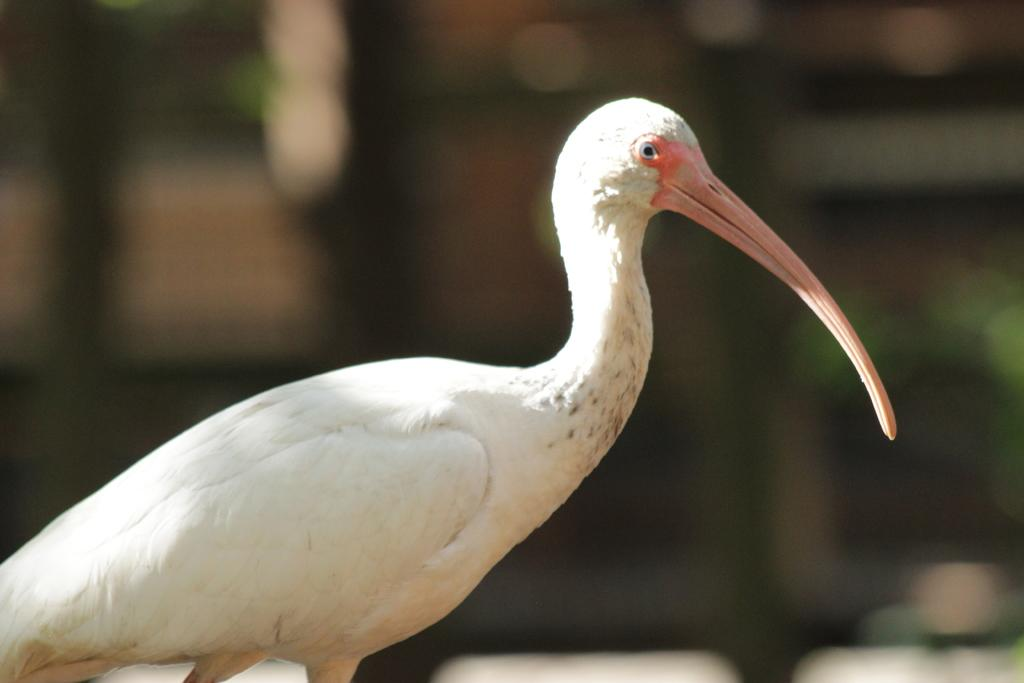What type of animal is in the image? There is a bird in the image. What color is the bird? The bird is white in color. Can you describe the background of the image? The background of the image is blurry. What type of plants can be seen in the image? There are no plants visible in the image; it features a white bird with a blurry background. 